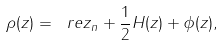<formula> <loc_0><loc_0><loc_500><loc_500>\rho ( z ) = \ r e z _ { n } + \frac { 1 } { 2 } H ( z ) + \phi ( z ) ,</formula> 